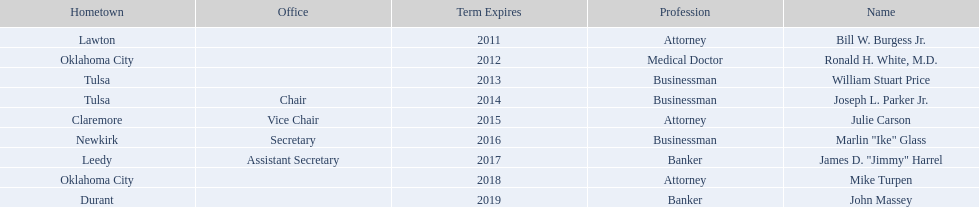How many of the current state regents have a listed office title? 4. 